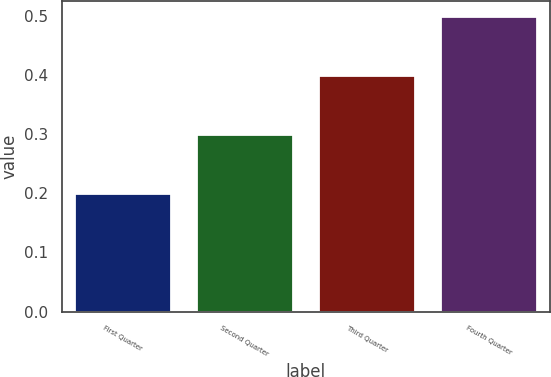Convert chart to OTSL. <chart><loc_0><loc_0><loc_500><loc_500><bar_chart><fcel>First Quarter<fcel>Second Quarter<fcel>Third Quarter<fcel>Fourth Quarter<nl><fcel>0.2<fcel>0.3<fcel>0.4<fcel>0.5<nl></chart> 